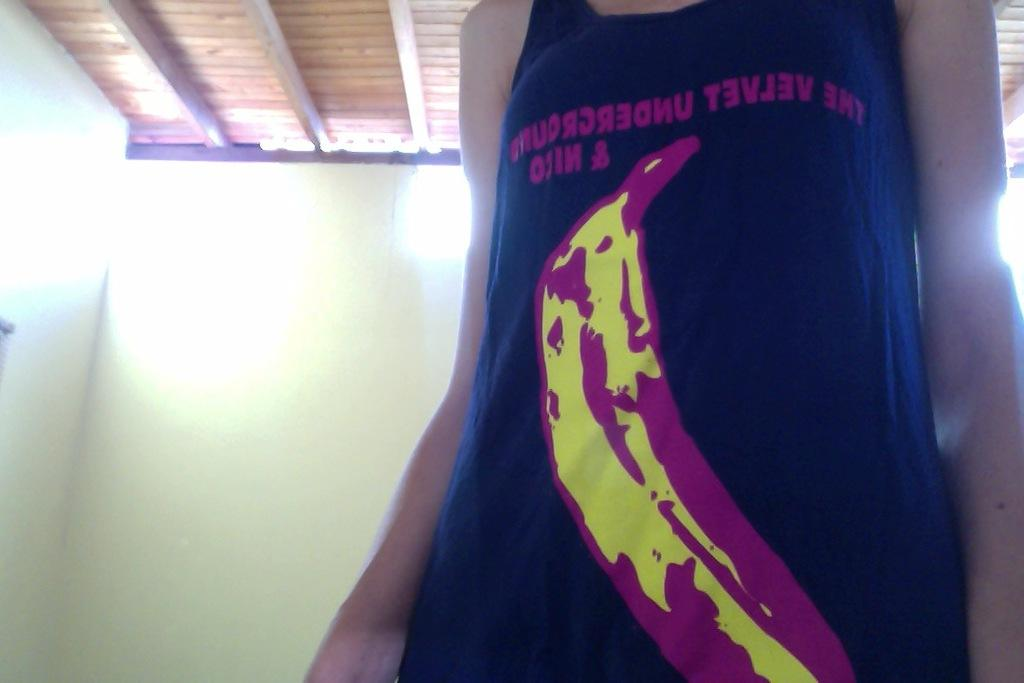<image>
Provide a brief description of the given image. A woman whose head you cannot see wears a black sleevless shirt with The Velvet Underground on it. 